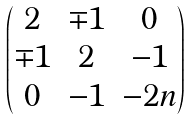Convert formula to latex. <formula><loc_0><loc_0><loc_500><loc_500>\begin{pmatrix} 2 & \mp 1 & 0 \\ \mp 1 & 2 & { - 1 } \\ 0 & { - 1 } & { - 2 n } \end{pmatrix}</formula> 